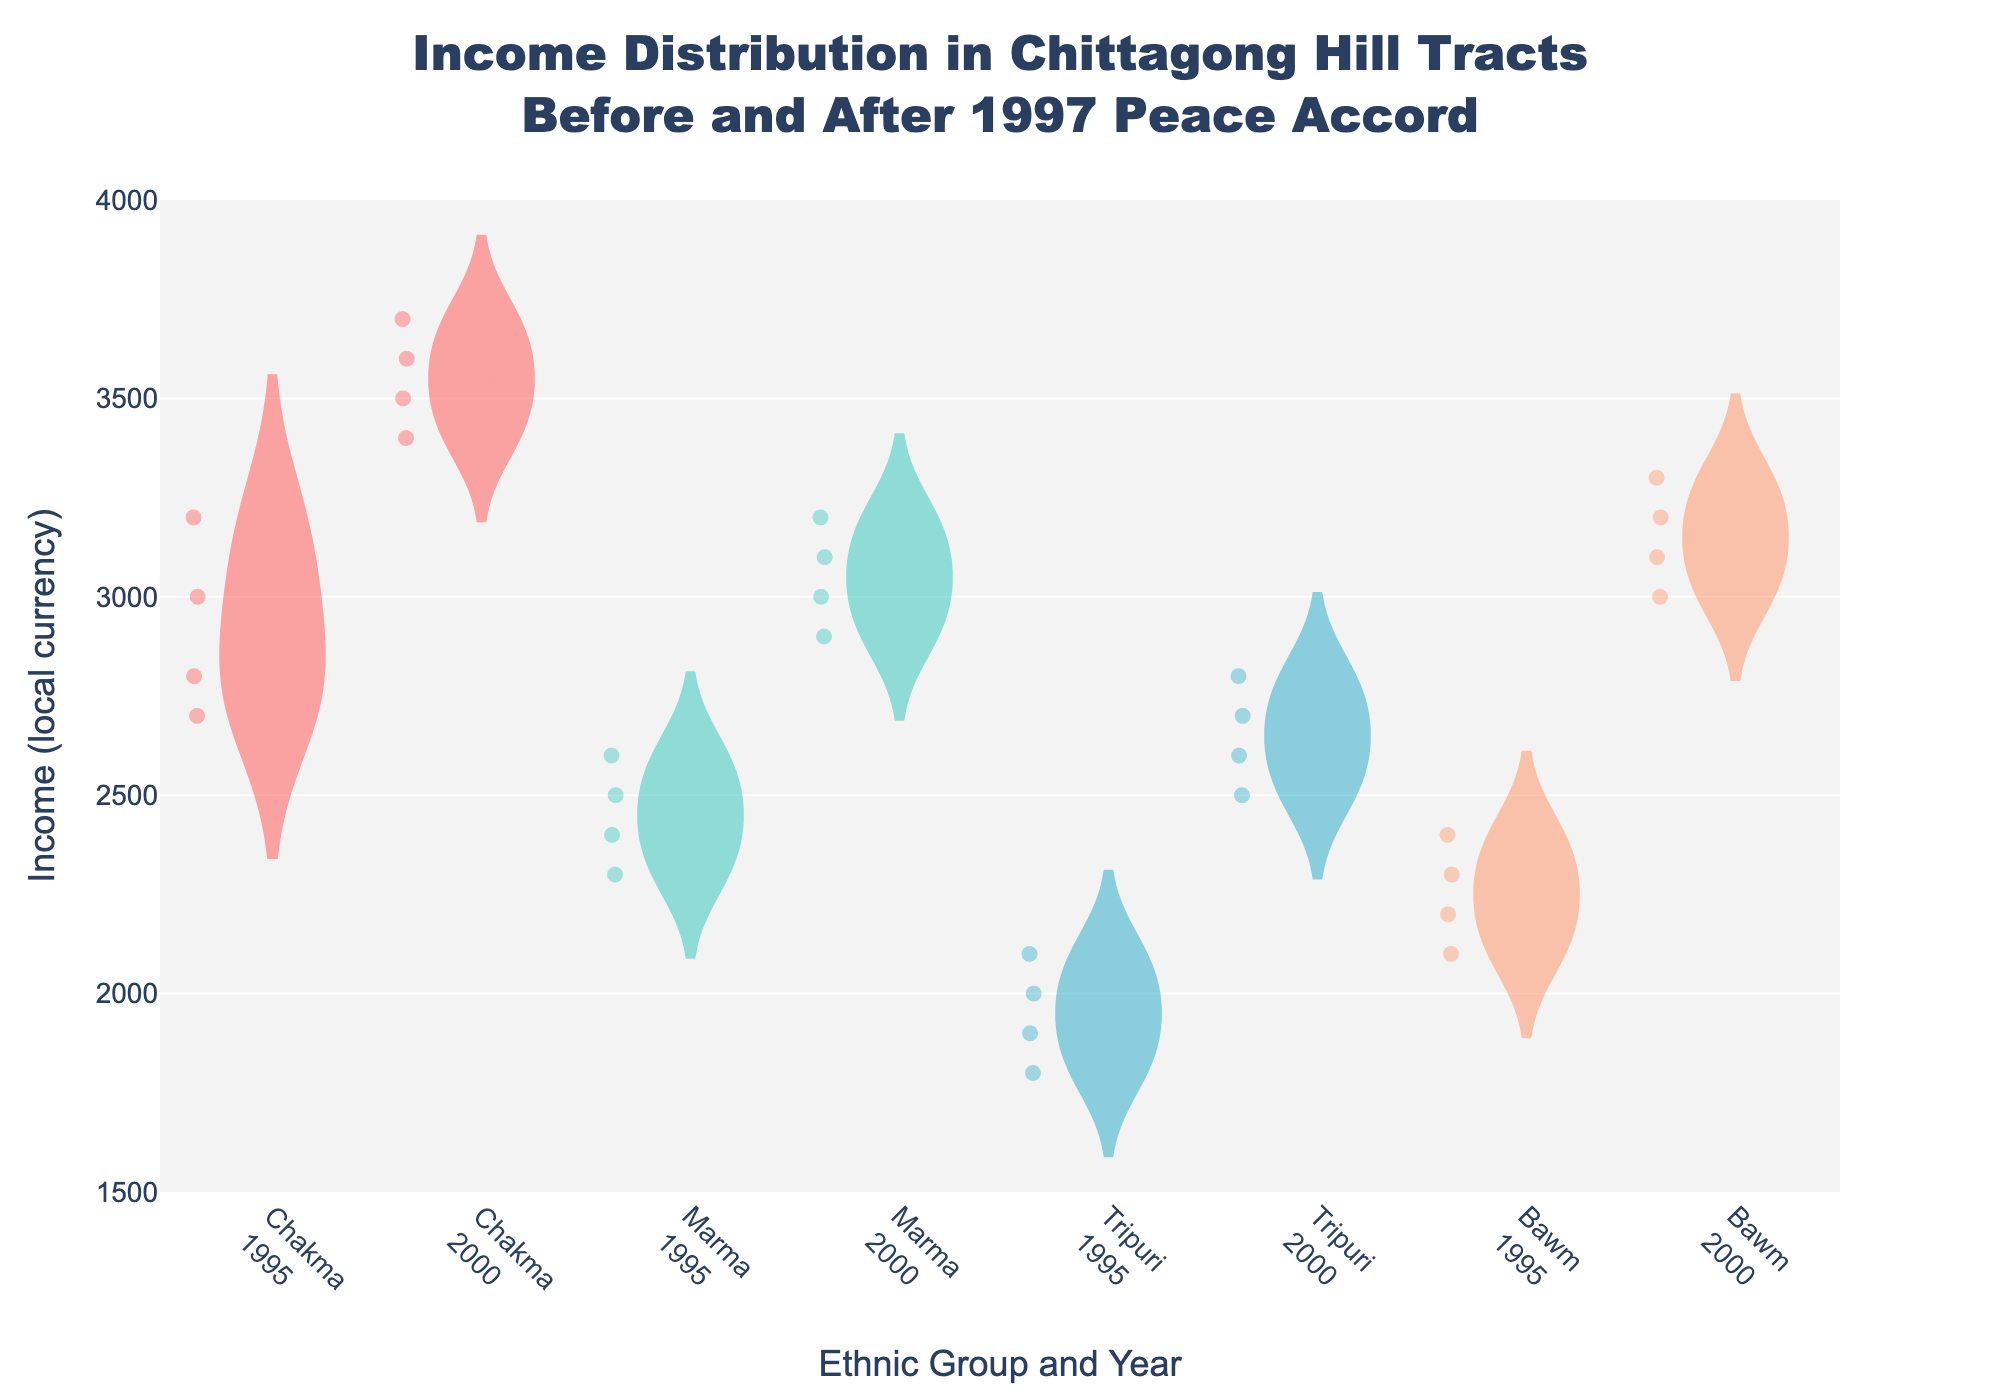What is the title of the chart? The title is displayed at the top of the figure. It defines the scope and context of the data presented.
Answer: Income Distribution in Chittagong Hill Tracts Before and After 1997 Peace Accord Which ethnic group shows the highest median income in the year 2000? The violin chart includes an indicator for median income, often represented by a line within each violin. By identifying the year 2000 and comparing the median lines among the ethnic groups, we can determine which group has the highest median.
Answer: Chakma How does the income distribution of Marma in 1995 compare to that in 2000? The shape and spread of the violin plots indicate the distribution. By comparing the violin plots of Marma for 1995 and 2000, we observe changes in spread and median positions.
Answer: The income distribution of Marma in 2000 is higher and more spread out compared to 1995 What is the range of incomes for the Bawm ethnic group in 2000? The range is determined by the minimum and maximum values within each violin plot. For the Bawm group in 2000, it’s the difference between the highest and lowest points in their violin plot.
Answer: 3000-3300 Which ethnic group had the lowest income distribution in 1995? By observing the overall spread and position of the violin plots for each ethnic group in 1995, we determine which has the lowest range of incomes.
Answer: Tripuri What is the average income for Chakma in 1995? To find the average, sum all data points for Chakma in 1995 and divide by the number of data points. Chakma 1995 incomes are 3000, 3200, 2800, 2700. Sum = 11700; Count = 4; Average = 11700 / 4.
Answer: 2925 Between 1995 and 2000, which ethnic group saw the most significant increase in median income? Comparing the median lines of each ethnic group from 1995 and 2000, the group with the largest vertical shift indicates the most significant increase.
Answer: Bawm Which ethnic group has the most dispersed income distribution in 1995? Dispersion is indicated by the width of the violin plot. The wider the plot, the more dispersed the income distribution.
Answer: Chakma How does the income distribution change for the Tripuri ethnic group from 1995 to 2000? Analyze the spread and median of the violin plots for Tripuri in both years. Changes in width and position of the plots indicate changes in income distribution.
Answer: The income distribution for Tripuri in 2000 is higher and shows a larger spread compared to 1995 What can be inferred about the impact of the 1997 Peace Accord on the income distribution across these ethnic groups? By comparing the overall shapes, medians, and spreads of the violin plots before and after 1997, we infer changes in economic well-being for each group influenced by the Accord.
Answer: The overall income distribution for most groups increased after the 1997 Peace Accord, indicating economic improvement 